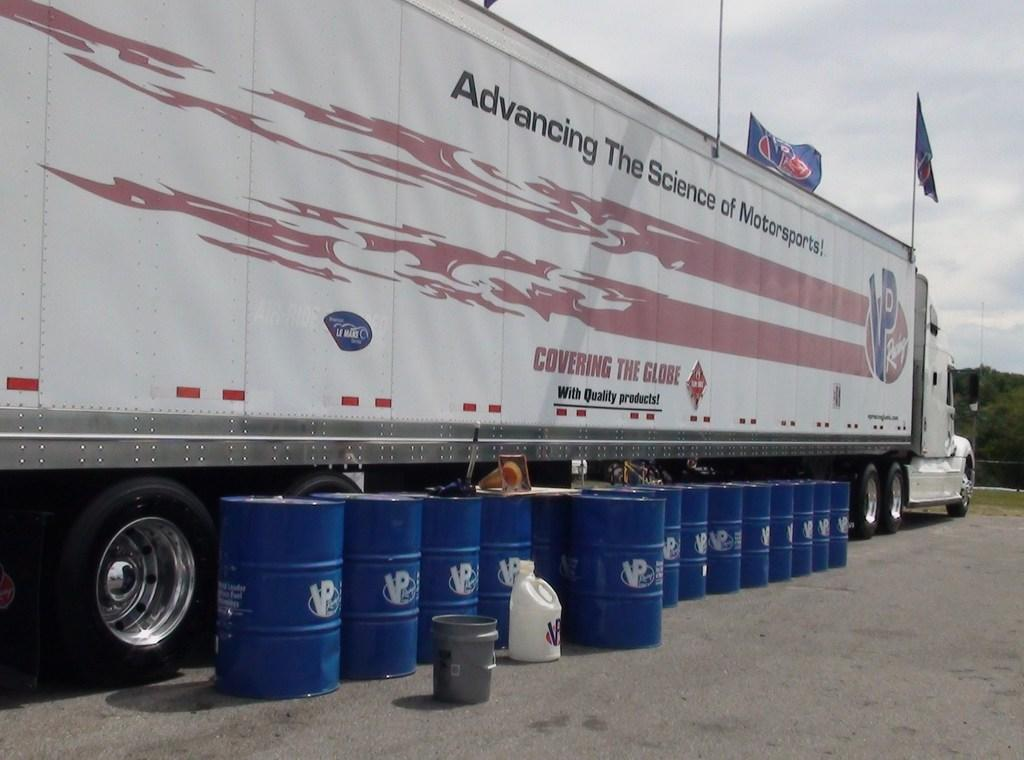What is the main subject of the image? The main subject of the image is a truck. What objects are near the truck in the image? There are barrels near the truck in the image. What can be seen in the background of the image? Trees and the sky are visible in the background of the image. Are there any weather conditions visible in the image? Yes, there are clouds in the background of the image. What type of rhythm can be heard coming from the truck in the image? There is no indication of sound or rhythm in the image, as it only features a truck, barrels, trees, and clouds. 